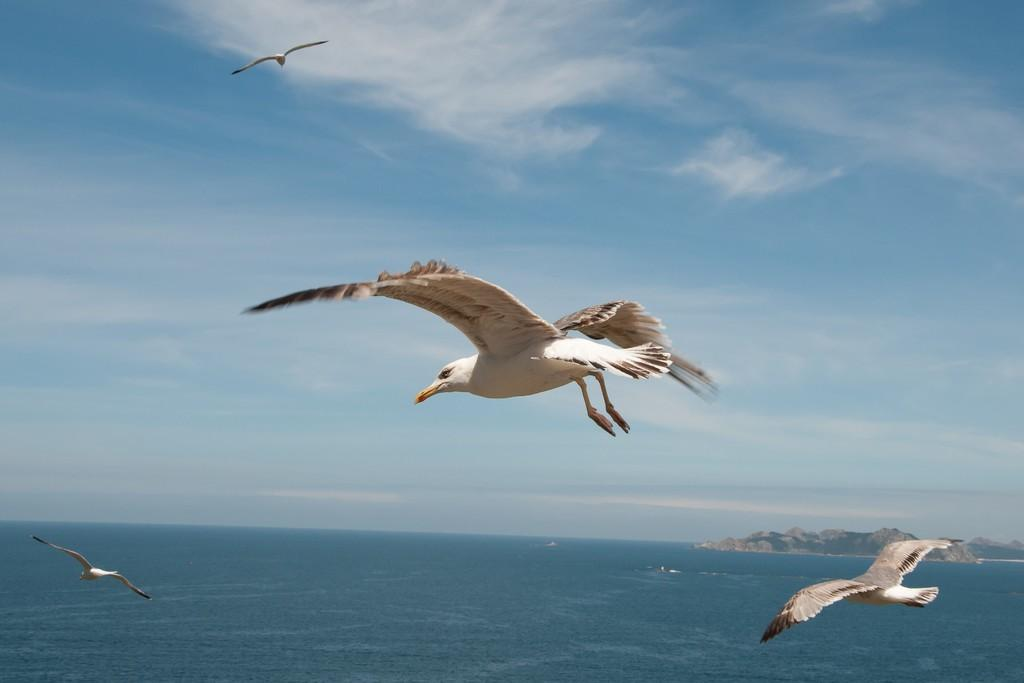What is the primary feature of the image? There is a water surface in the image. What can be seen in the background of the image? There are mountains visible in the image. What is happening in the sky above the water surface? There are birds flying in the sky above the water surface. Where is the airport located in the image? There is no airport present in the image. What type of can is floating on the water surface? There is no can present in the image; it only features a water surface, mountains, and birds flying. 